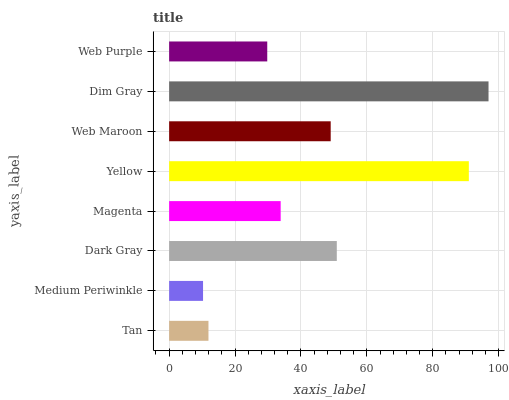Is Medium Periwinkle the minimum?
Answer yes or no. Yes. Is Dim Gray the maximum?
Answer yes or no. Yes. Is Dark Gray the minimum?
Answer yes or no. No. Is Dark Gray the maximum?
Answer yes or no. No. Is Dark Gray greater than Medium Periwinkle?
Answer yes or no. Yes. Is Medium Periwinkle less than Dark Gray?
Answer yes or no. Yes. Is Medium Periwinkle greater than Dark Gray?
Answer yes or no. No. Is Dark Gray less than Medium Periwinkle?
Answer yes or no. No. Is Web Maroon the high median?
Answer yes or no. Yes. Is Magenta the low median?
Answer yes or no. Yes. Is Dim Gray the high median?
Answer yes or no. No. Is Dim Gray the low median?
Answer yes or no. No. 